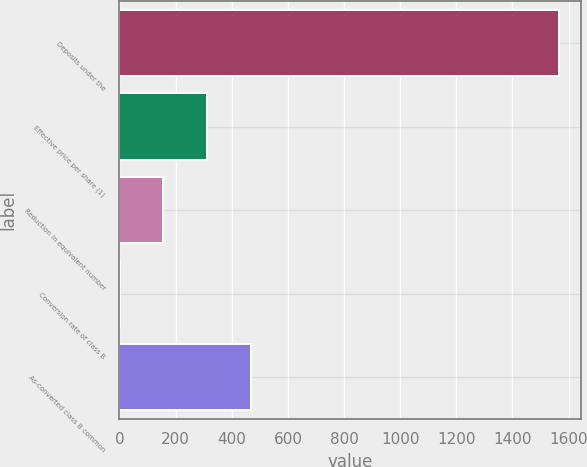Convert chart to OTSL. <chart><loc_0><loc_0><loc_500><loc_500><bar_chart><fcel>Deposits under the<fcel>Effective price per share (1)<fcel>Reduction in equivalent number<fcel>Conversion rate of class B<fcel>As-converted class B common<nl><fcel>1565<fcel>313.35<fcel>156.89<fcel>0.43<fcel>469.81<nl></chart> 